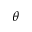Convert formula to latex. <formula><loc_0><loc_0><loc_500><loc_500>\theta</formula> 